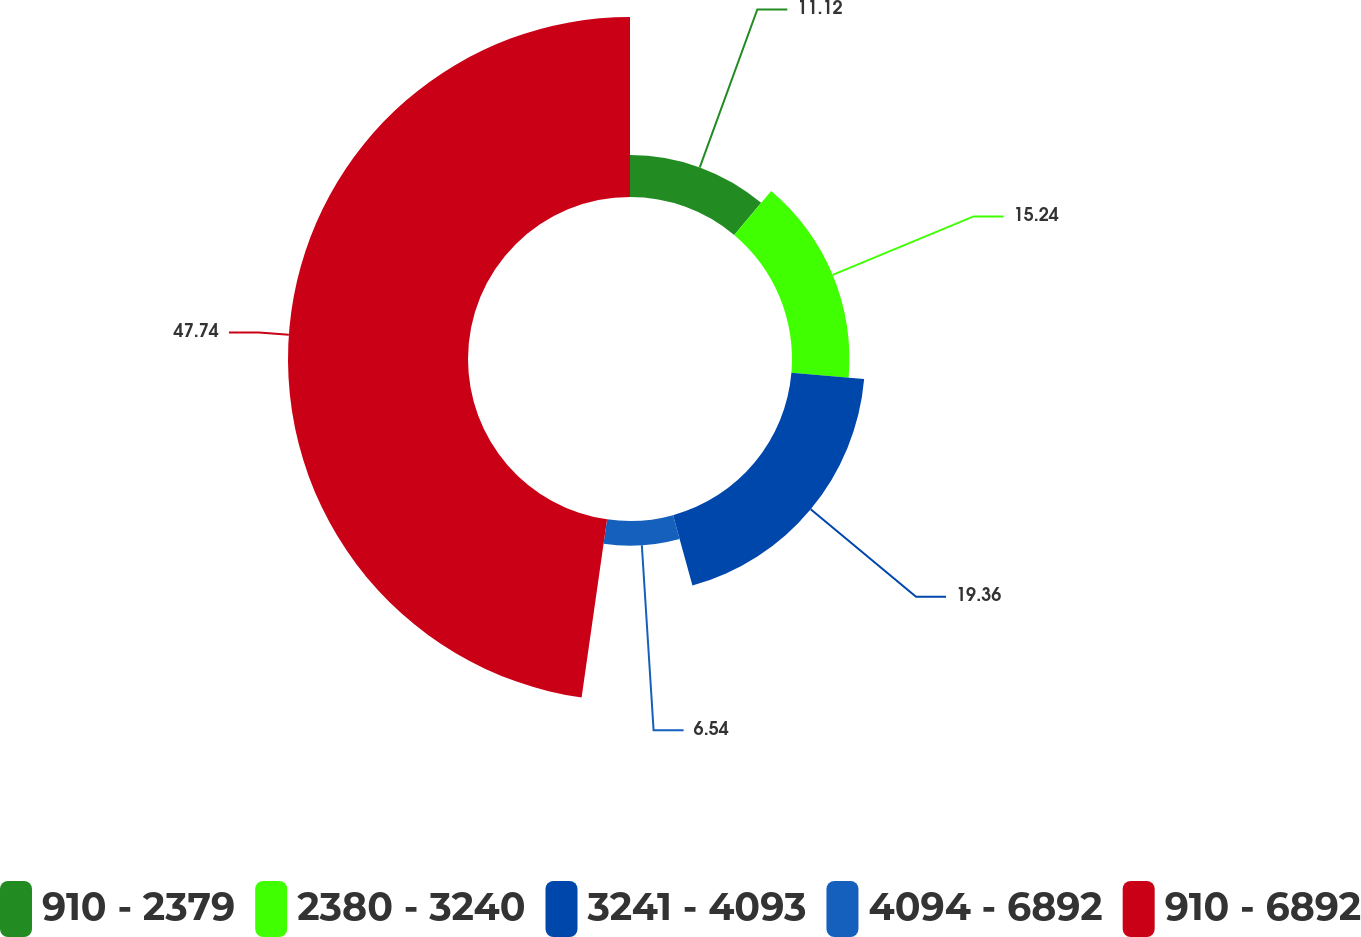Convert chart to OTSL. <chart><loc_0><loc_0><loc_500><loc_500><pie_chart><fcel>910 - 2379<fcel>2380 - 3240<fcel>3241 - 4093<fcel>4094 - 6892<fcel>910 - 6892<nl><fcel>11.12%<fcel>15.24%<fcel>19.36%<fcel>6.54%<fcel>47.74%<nl></chart> 